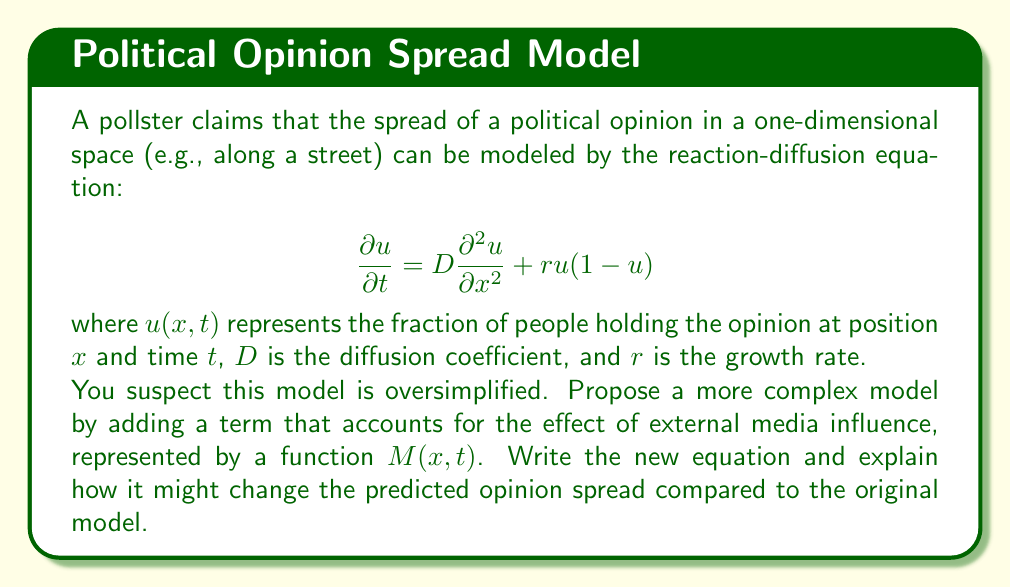Provide a solution to this math problem. To create a more complex and potentially more accurate model, we can add a term to account for external media influence. This addition reflects the real-world scenario where people's opinions are not only affected by local interactions (diffusion) and personal growth (reaction) but also by external sources of information.

Let's modify the equation as follows:

$$\frac{\partial u}{\partial t} = D\frac{\partial^2 u}{\partial x^2} + ru(1-u) + \alpha M(x,t)(1-u)$$

Where:
- $\alpha$ is a coefficient representing the strength of media influence
- $M(x,t)$ is a function representing the media influence, which can vary with position and time
- The term $\alpha M(x,t)(1-u)$ represents the media's ability to influence those who don't yet hold the opinion (1-u)

This new model differs from the original in several ways:

1. Variable influence: The media term $M(x,t)$ allows for spatially and temporally varying external influence, which is more realistic than assuming uniform conditions.

2. Saturation effect: The $(1-u)$ factor in the media term ensures that as $u$ approaches 1, the effect of media diminishes, reflecting the difficulty of convincing those who already hold the opinion.

3. Potential for opinion reversal: If $M(x,t)$ can take negative values, it could model media influence that opposes the spread of the opinion.

4. Non-linear dynamics: The addition of the media term introduces more complex non-linear behavior, potentially leading to multiple equilibria or pattern formation that wasn't possible in the simpler model.

5. Spatial heterogeneity: If $M(x,t)$ varies with $x$, it can lead to spatial patterns in opinion distribution that wouldn't emerge in the original model.

This enhanced model would likely predict:
- Faster opinion spread in areas with strong positive media influence
- Possible opinion regression in areas with negative media influence
- More complex spatial patterns of opinion distribution
- Potential for sudden shifts in opinion due to media events

These predictions challenge the accuracy of the original model by introducing more realistic factors that influence opinion dynamics.
Answer: $$\frac{\partial u}{\partial t} = D\frac{\partial^2 u}{\partial x^2} + ru(1-u) + \alpha M(x,t)(1-u)$$ 